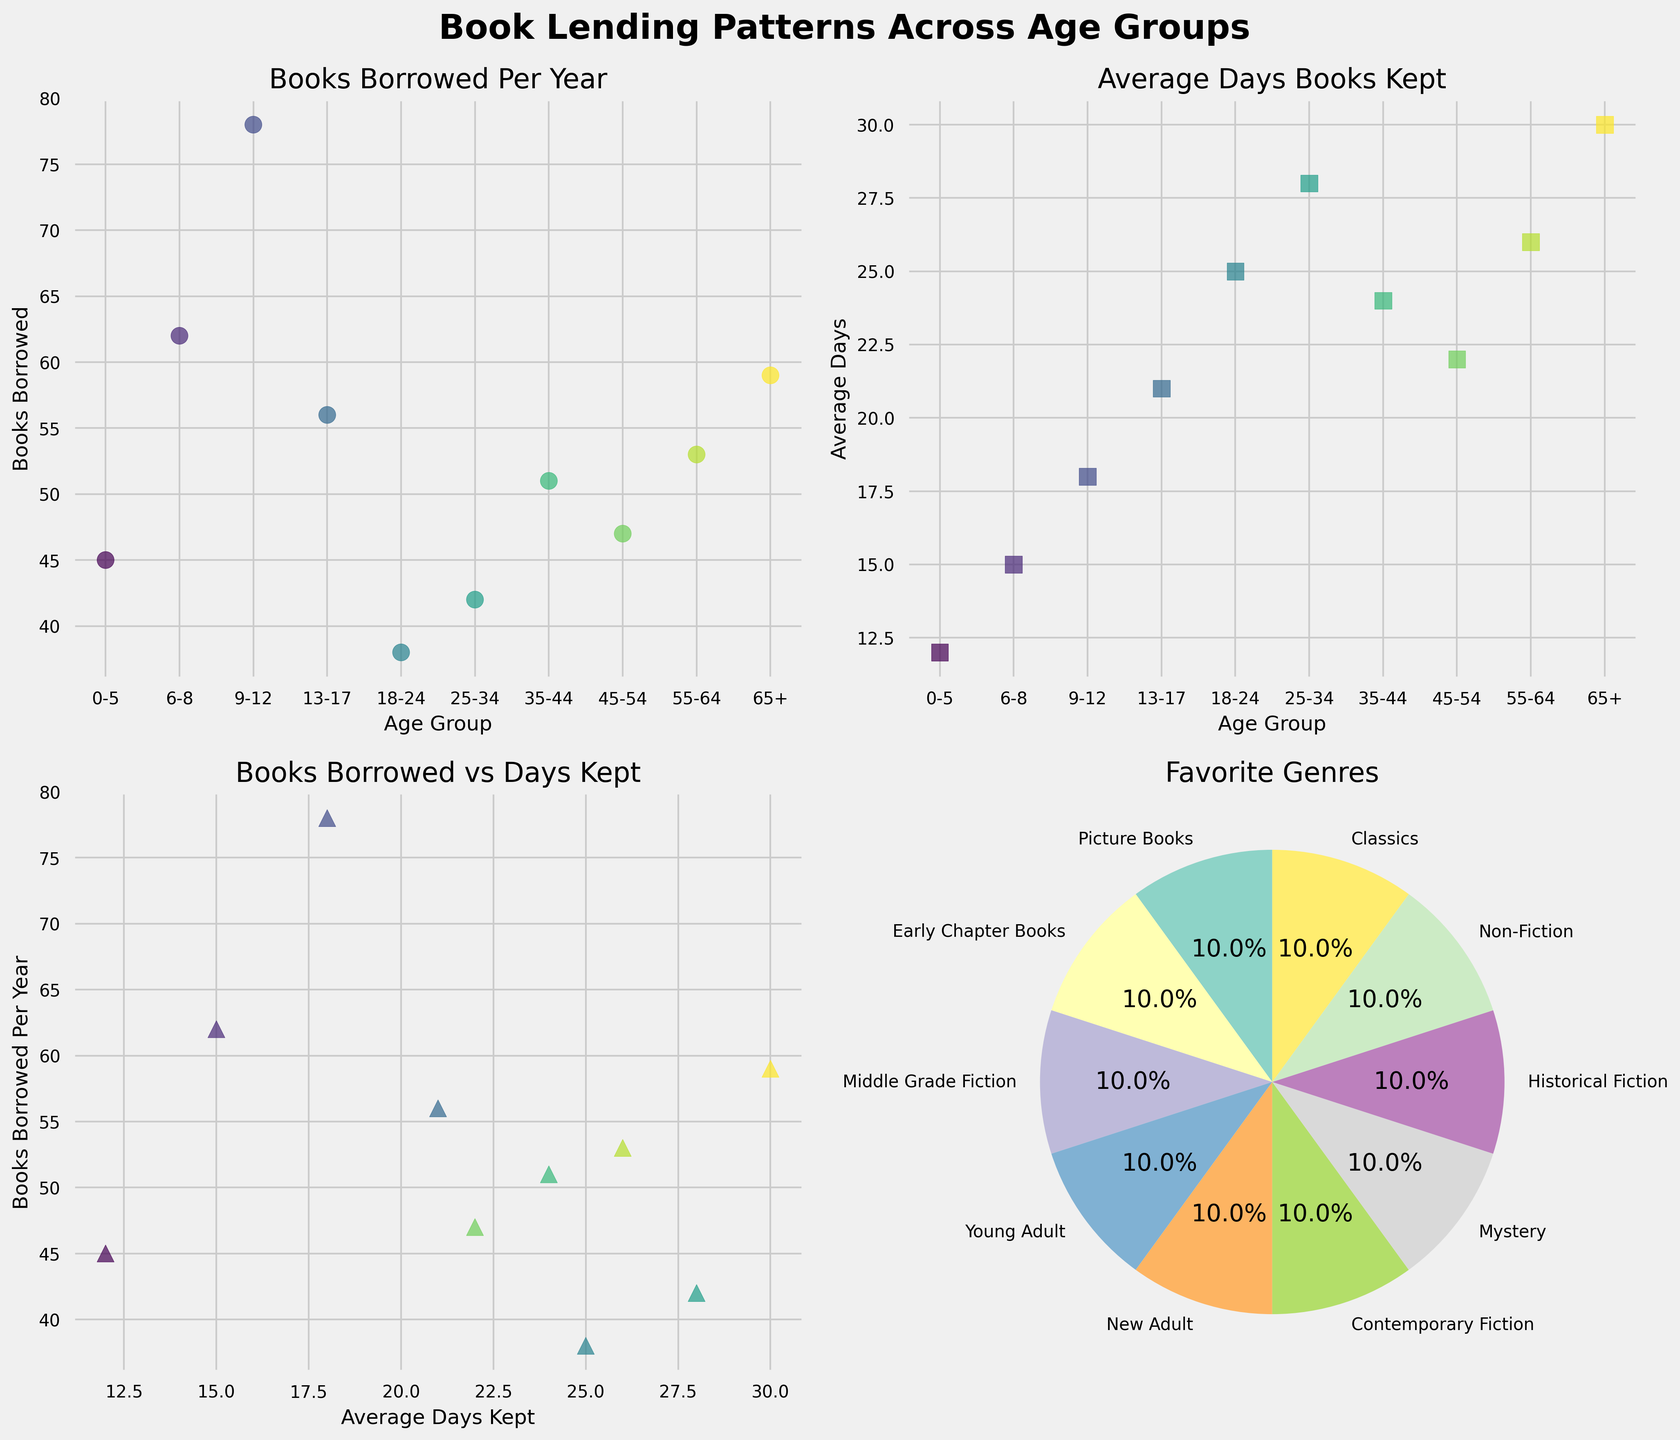What's the title of the figure? The title is prominently displayed at the top of the figure. It reads "Book Lending Patterns Across Age Groups," which provides an overview of the content illustrated in the subplots.
Answer: Book Lending Patterns Across Age Groups Which age group borrows the most books per year? In the subplot showing "Books Borrowed Per Year," the age group labelled 9-12 (Middle Grade Fiction) has the highest point on the y-axis, indicating they borrow the most books per year.
Answer: 9-12 What is the average number of days books are kept for the age group 35-44? In the subplot for "Average Days Books Kept," the point corresponding to the 35-44 age group is at 24 on the y-axis.
Answer: 24 How many favorite genres are displayed in the pie chart? By counting the segments in the pie chart in the subplot titled "Favorite Genres," you can determine there are 10 different favorite genres displayed.
Answer: 10 Which age group keeps books for the longest average time? In the subplot "Average Days Books Kept," the point at the highest position on the y-axis corresponds to the age group 65+ (Classics), indicating they keep books for the longest average time.
Answer: 65+ What is the ratio of books borrowed to average days kept for the age group 13-17? For the 13-17 age group, the subplot "Books Borrowed vs Days Kept" shows a point where the x-value (Average Days Kept) is 21 and the y-value (Books Borrowed) is 56. The ratio is calculated as 56/21.
Answer: 2.67 Which two age groups have similar patterns in both books borrowed per year and average days books are kept? Upon examining both the "Books Borrowed Per Year" and "Average Days Books Kept" subplots, the age groups 45-54 and 55-64 show similar values in both metrics, clustering closely together.
Answer: 45-54 and 55-64 At which age group does the number of books borrowed per year decrease significantly compared to the previous age group? The subplot "Books Borrowed Per Year" shows a significant drop from the 9-12 age group (78 books) to the 13-17 age group (56 books), indicating a notable decrease.
Answer: 13-17 What is the favorite genre for the age group 25-34? Based on the information in the question data, the favorite genre for the 25-34 age group is Contemporary Fiction. There's no need to refer to the figure for this information.
Answer: Contemporary Fiction 